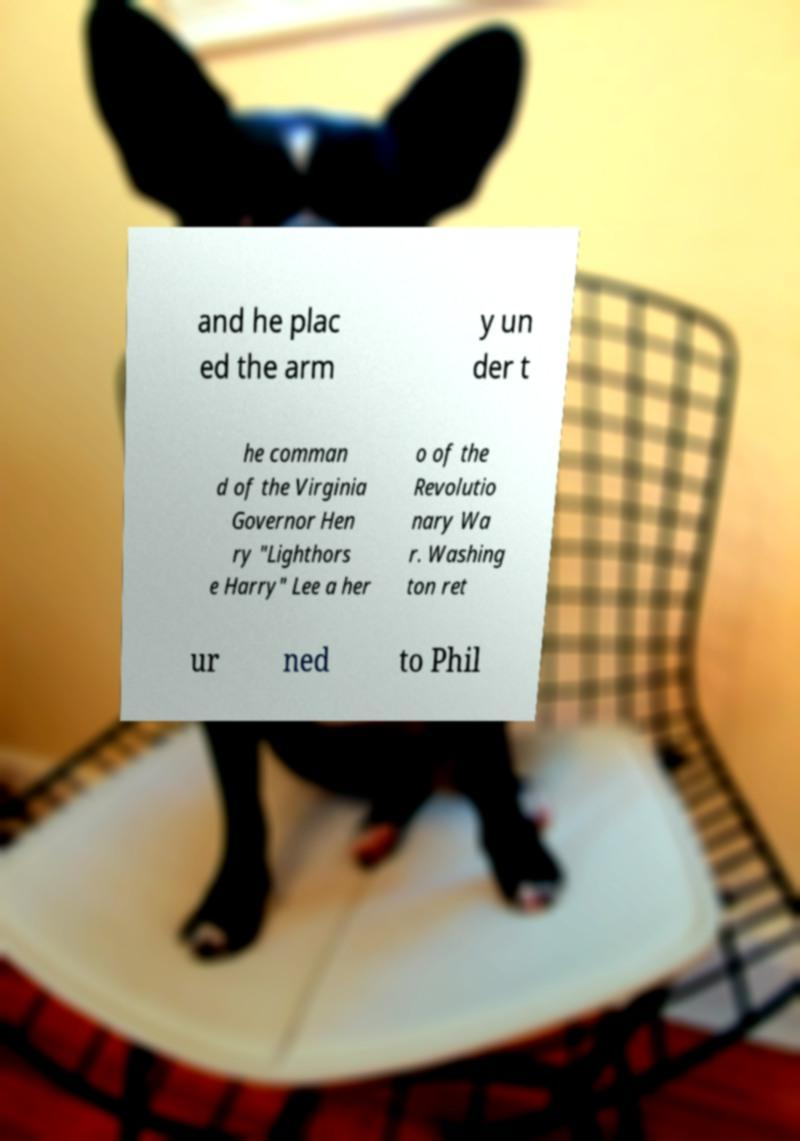For documentation purposes, I need the text within this image transcribed. Could you provide that? and he plac ed the arm y un der t he comman d of the Virginia Governor Hen ry "Lighthors e Harry" Lee a her o of the Revolutio nary Wa r. Washing ton ret ur ned to Phil 